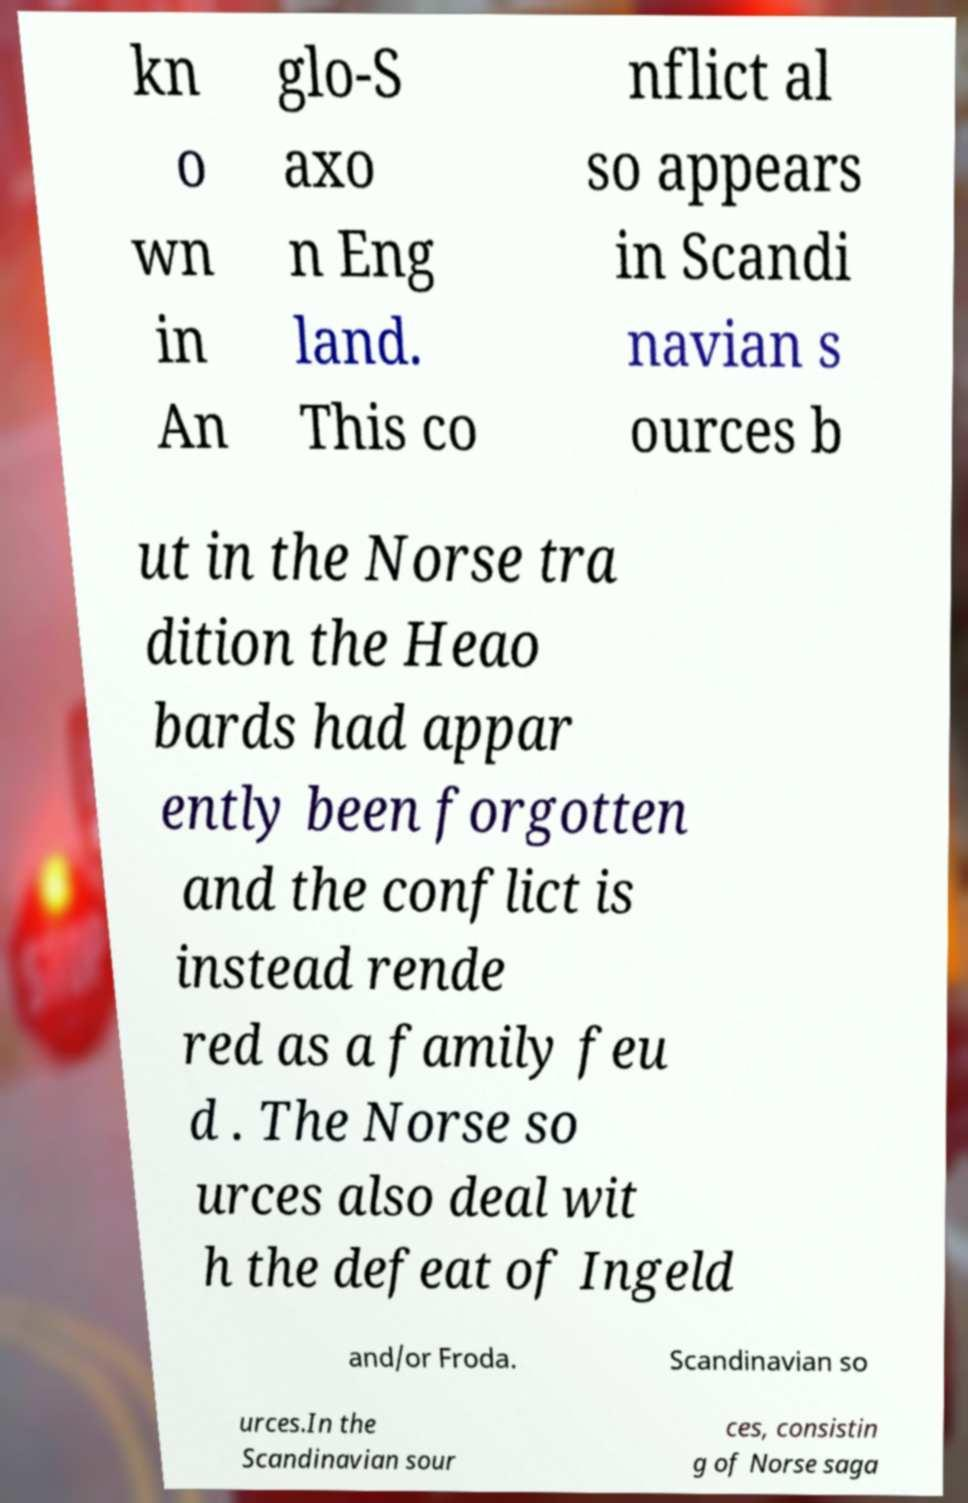Could you assist in decoding the text presented in this image and type it out clearly? kn o wn in An glo-S axo n Eng land. This co nflict al so appears in Scandi navian s ources b ut in the Norse tra dition the Heao bards had appar ently been forgotten and the conflict is instead rende red as a family feu d . The Norse so urces also deal wit h the defeat of Ingeld and/or Froda. Scandinavian so urces.In the Scandinavian sour ces, consistin g of Norse saga 